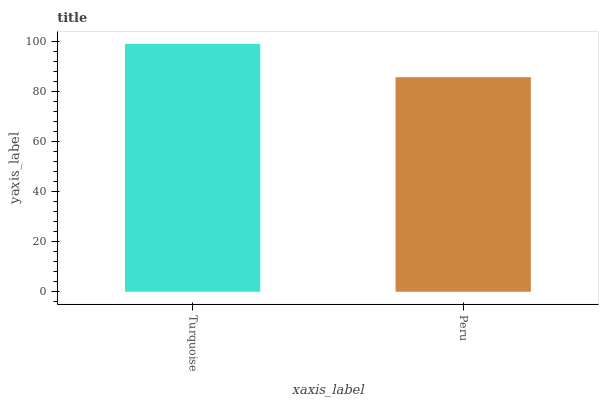Is Peru the minimum?
Answer yes or no. Yes. Is Turquoise the maximum?
Answer yes or no. Yes. Is Peru the maximum?
Answer yes or no. No. Is Turquoise greater than Peru?
Answer yes or no. Yes. Is Peru less than Turquoise?
Answer yes or no. Yes. Is Peru greater than Turquoise?
Answer yes or no. No. Is Turquoise less than Peru?
Answer yes or no. No. Is Turquoise the high median?
Answer yes or no. Yes. Is Peru the low median?
Answer yes or no. Yes. Is Peru the high median?
Answer yes or no. No. Is Turquoise the low median?
Answer yes or no. No. 